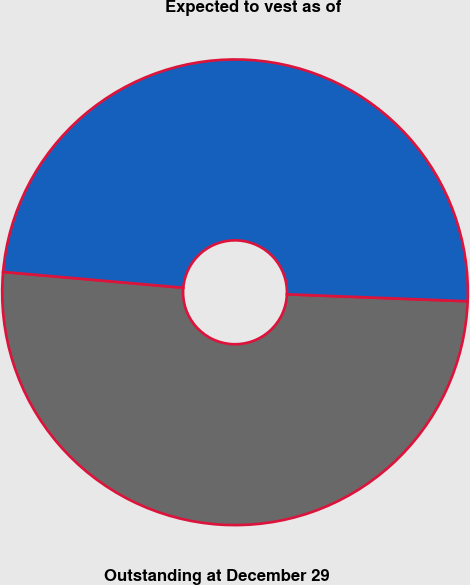Convert chart. <chart><loc_0><loc_0><loc_500><loc_500><pie_chart><fcel>Outstanding at December 29<fcel>Expected to vest as of<nl><fcel>50.78%<fcel>49.22%<nl></chart> 